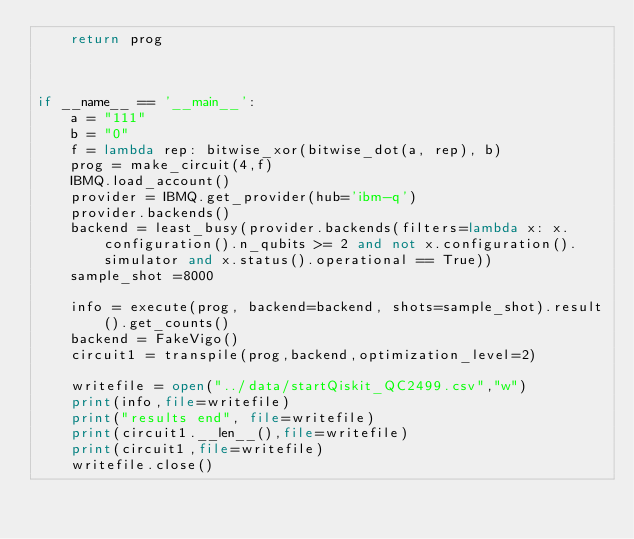Convert code to text. <code><loc_0><loc_0><loc_500><loc_500><_Python_>    return prog



if __name__ == '__main__':
    a = "111"
    b = "0"
    f = lambda rep: bitwise_xor(bitwise_dot(a, rep), b)
    prog = make_circuit(4,f)
    IBMQ.load_account() 
    provider = IBMQ.get_provider(hub='ibm-q') 
    provider.backends()
    backend = least_busy(provider.backends(filters=lambda x: x.configuration().n_qubits >= 2 and not x.configuration().simulator and x.status().operational == True))
    sample_shot =8000

    info = execute(prog, backend=backend, shots=sample_shot).result().get_counts()
    backend = FakeVigo()
    circuit1 = transpile(prog,backend,optimization_level=2)

    writefile = open("../data/startQiskit_QC2499.csv","w")
    print(info,file=writefile)
    print("results end", file=writefile)
    print(circuit1.__len__(),file=writefile)
    print(circuit1,file=writefile)
    writefile.close()
</code> 